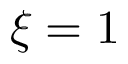<formula> <loc_0><loc_0><loc_500><loc_500>\xi = 1</formula> 